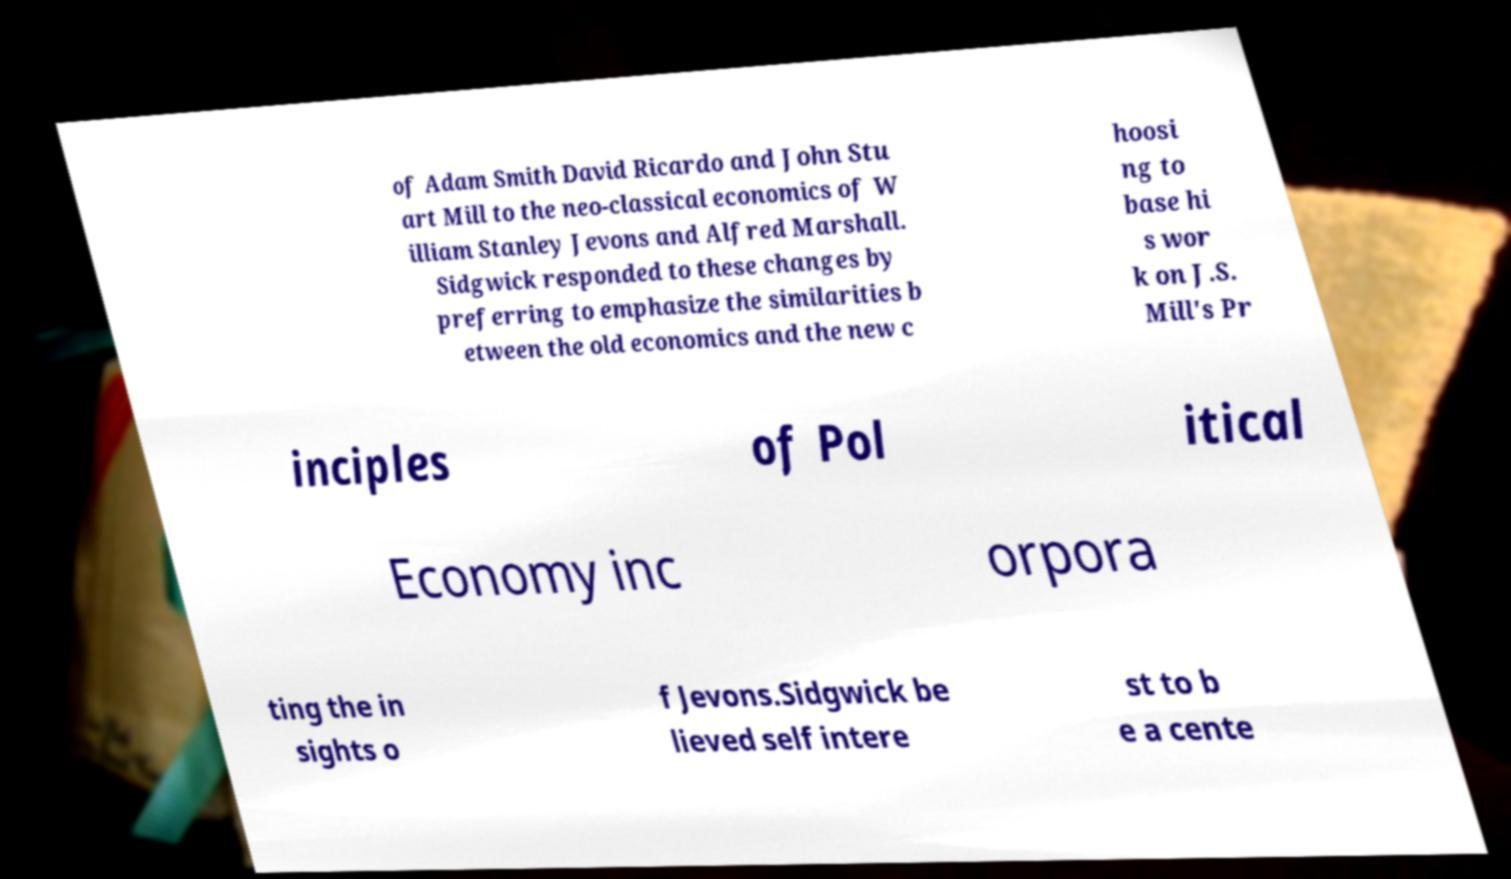There's text embedded in this image that I need extracted. Can you transcribe it verbatim? of Adam Smith David Ricardo and John Stu art Mill to the neo-classical economics of W illiam Stanley Jevons and Alfred Marshall. Sidgwick responded to these changes by preferring to emphasize the similarities b etween the old economics and the new c hoosi ng to base hi s wor k on J.S. Mill's Pr inciples of Pol itical Economy inc orpora ting the in sights o f Jevons.Sidgwick be lieved self intere st to b e a cente 